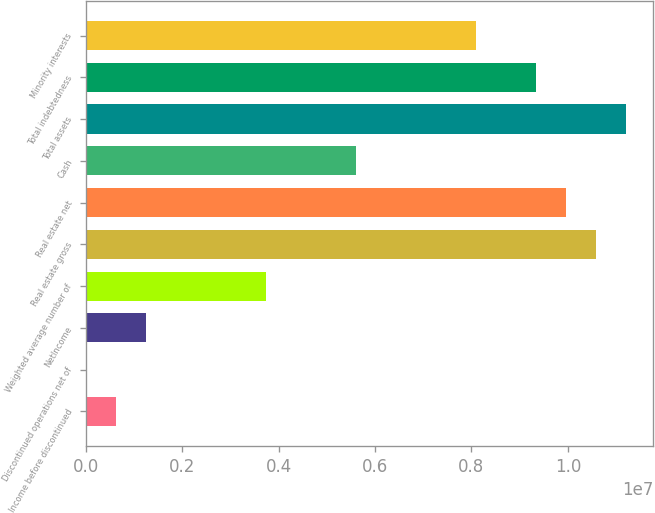Convert chart. <chart><loc_0><loc_0><loc_500><loc_500><bar_chart><fcel>Income before discontinued<fcel>Discontinued operations net of<fcel>NetIncome<fcel>Weighted average number of<fcel>Real estate gross<fcel>Real estate net<fcel>Cash<fcel>Total assets<fcel>Total indebtedness<fcel>Minority interests<nl><fcel>622647<fcel>0.24<fcel>1.24529e+06<fcel>3.73588e+06<fcel>1.0585e+07<fcel>9.96235e+06<fcel>5.60382e+06<fcel>1.12076e+07<fcel>9.3397e+06<fcel>8.09441e+06<nl></chart> 